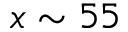Convert formula to latex. <formula><loc_0><loc_0><loc_500><loc_500>x \sim 5 5</formula> 